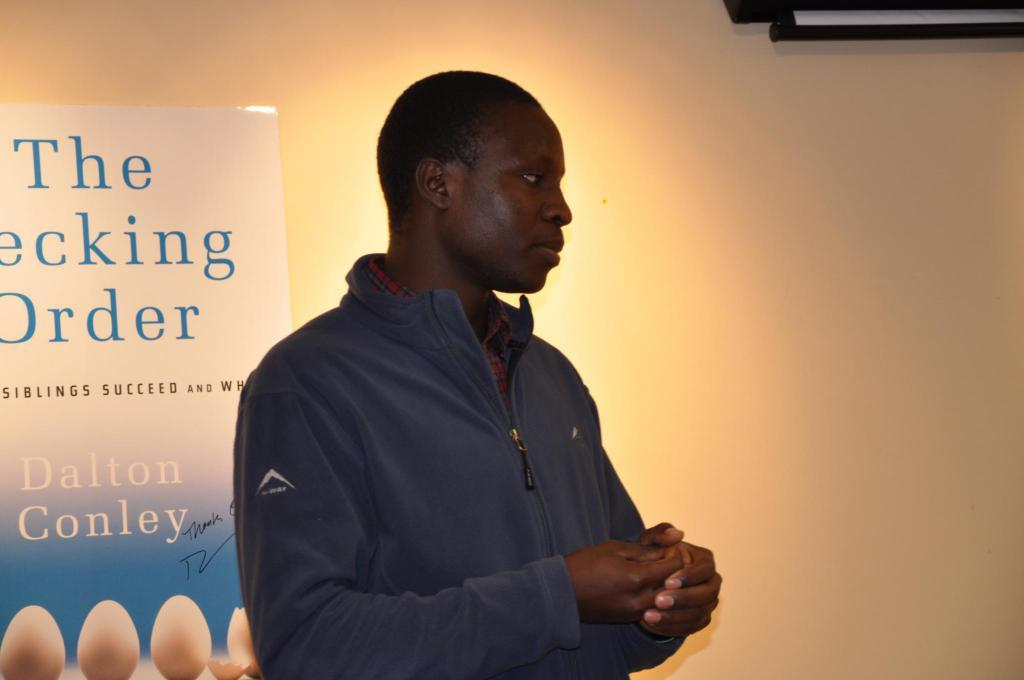What is the main subject of the image? There is a person standing in the middle of the image. What is the person doing in the image? The person is watching something. What can be seen behind the person in the image? There is a banner behind the person. What type of beetle can be seen crawling on the person's shoulder in the image? There is no beetle present on the person's shoulder in the image. Is the person wearing a ring on their finger in the image? The image does not provide information about any rings on the person's fingers. 